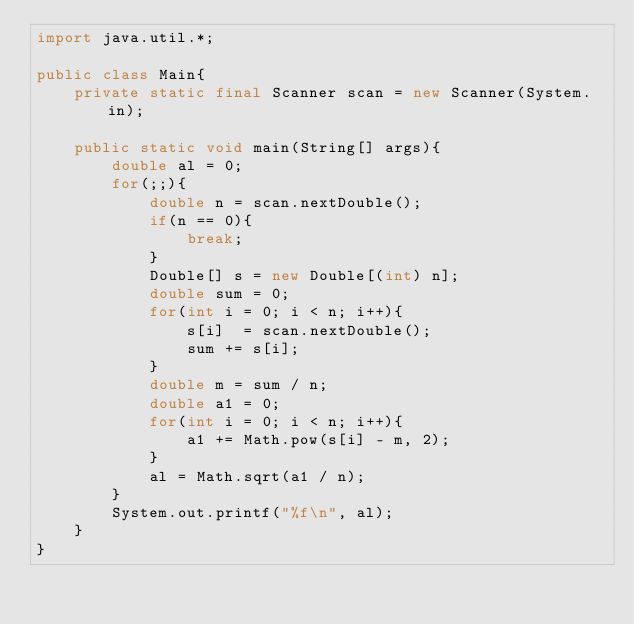Convert code to text. <code><loc_0><loc_0><loc_500><loc_500><_Java_>import java.util.*;

public class Main{
	private static final Scanner scan = new Scanner(System.in);

	public static void main(String[] args){
		double al = 0;
		for(;;){
			double n = scan.nextDouble();
			if(n == 0){
				break;
			}
			Double[] s = new Double[(int) n];
			double sum = 0;
			for(int i = 0; i < n; i++){
				s[i]  = scan.nextDouble();
				sum += s[i];
			}
			double m = sum / n;
			double a1 = 0;
			for(int i = 0; i < n; i++){
				a1 += Math.pow(s[i] - m, 2);
			}
			al = Math.sqrt(a1 / n);
		}
		System.out.printf("%f\n", al);
	}
}</code> 